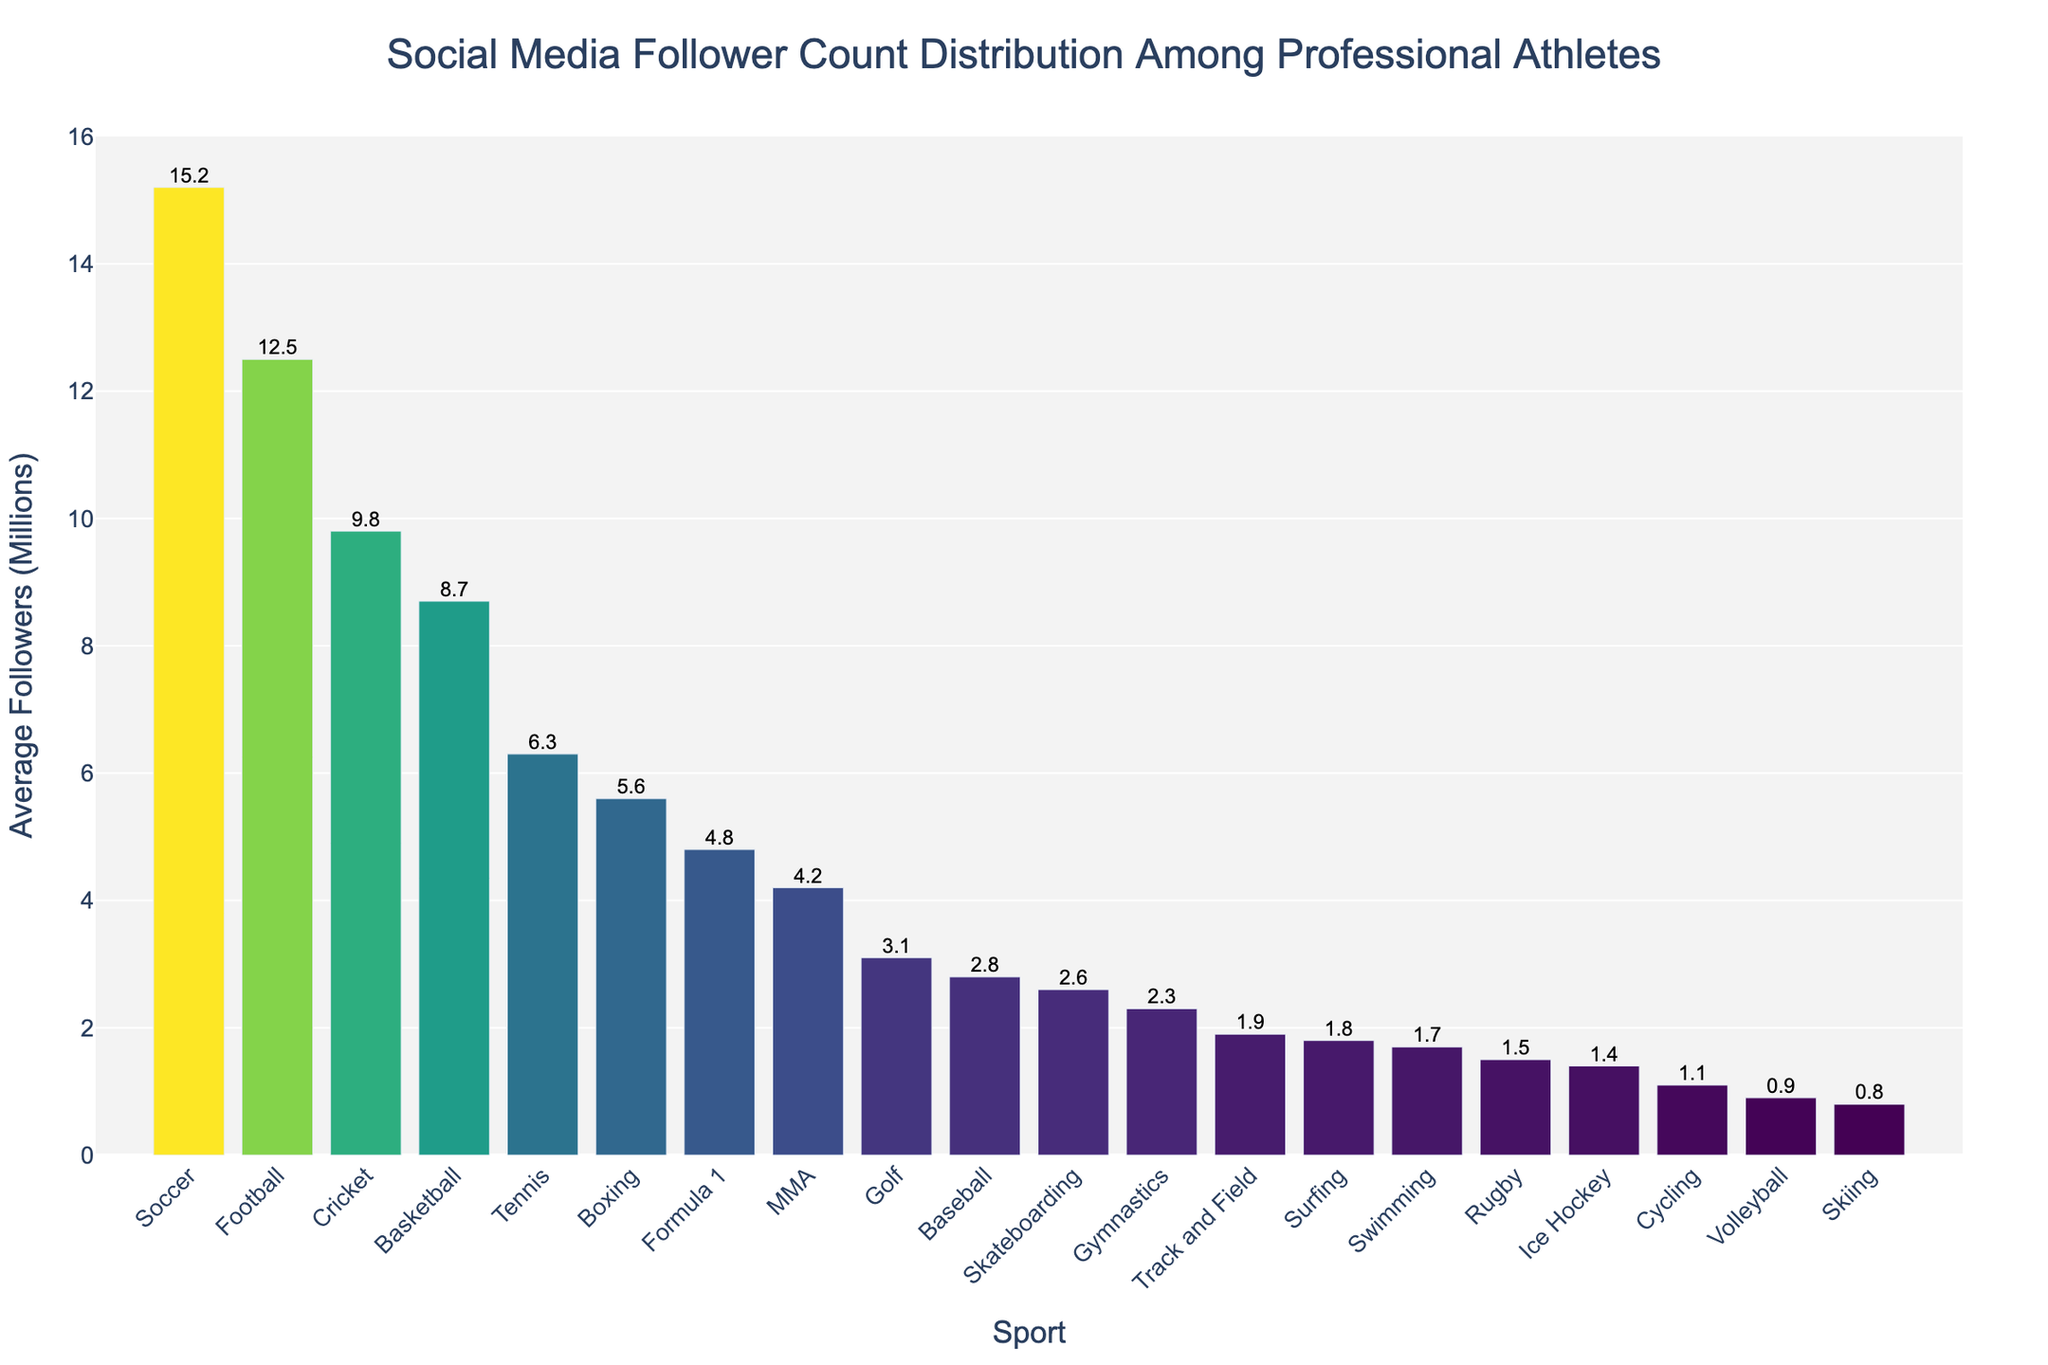What sport has the highest average social media follower count? The highest bar represents Soccer with an average follower count of 15.2 million.
Answer: Soccer Which two sports have the lowest average follower counts, and what are their values? The two shortest bars represent Skiing and Volleyball with average follower counts of 0.8 million and 0.9 million, respectively.
Answer: Skiing and Volleyball: 0.8 million and 0.9 million How much higher is the average follower count for Football compared to Tennis? Football has 12.5 million followers, and Tennis has 6.3 million. The difference is 12.5 - 6.3 = 6.2 million followers.
Answer: 6.2 million What is the total average follower count for Golf, Baseball, and Track and Field combined? Adding the average follower counts: Golf (3.1 million) + Baseball (2.8 million) + Track and Field (1.9 million) = 3.1 + 2.8 + 1.9 = 7.8 million followers.
Answer: 7.8 million Compare the average follower counts between MMA and Boxing. Which one is higher and by how much? MMA has 4.2 million followers, and Boxing has 5.6 million. Boxing is higher by 5.6 - 4.2 = 1.4 million followers.
Answer: Boxing by 1.4 million Which sport has an average follower count closest to 2 million, and what is the exact value? Track and Field and Surfing have counts close to 2 million. Track and Field has 1.9 million and Surfing has 1.8 million. Track and Field is closest to 2 million.
Answer: Track and Field: 1.9 million What is the average follower count for sports with more than 10 million followers? The sports are Soccer with 15.2 million and Football with 12.5 million. Their average is (15.2 + 12.5)/2 = 27.7/2 = 13.85 million.
Answer: 13.85 million How does the average follower count for Cricket compare to Formula 1, and what is the difference? Cricket has 9.8 million followers, and Formula 1 has 4.8 million. Cricket has 9.8 - 4.8 = 5 million more followers.
Answer: Cricket by 5 million What is the combined total follower count for the three sports at the bottom of the chart? The three sports with the lowest follower counts are Skiing (0.8 million), Volleyball (0.9 million), and Cycling (1.1 million). The combined total is 0.8 + 0.9 + 1.1 = 2.8 million followers.
Answer: 2.8 million 